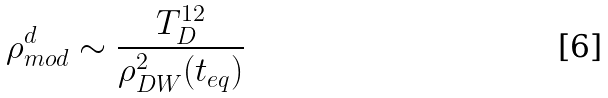<formula> <loc_0><loc_0><loc_500><loc_500>\rho ^ { d } _ { m o d } \sim \frac { T _ { D } ^ { 1 2 } } { \rho ^ { 2 } _ { D W } ( t _ { e q } ) }</formula> 